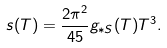<formula> <loc_0><loc_0><loc_500><loc_500>s ( T ) = \frac { 2 \pi ^ { 2 } } { 4 5 } g _ { * S } ( T ) T ^ { 3 } .</formula> 